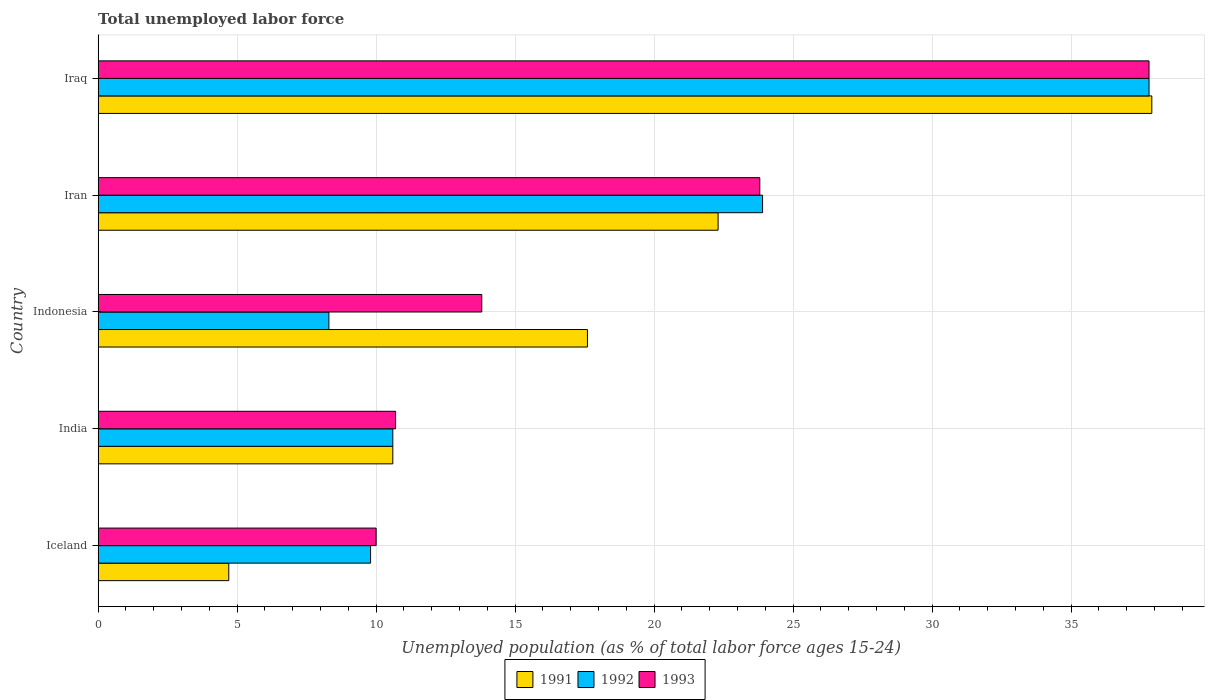How many different coloured bars are there?
Offer a terse response. 3. Are the number of bars per tick equal to the number of legend labels?
Make the answer very short. Yes. Are the number of bars on each tick of the Y-axis equal?
Give a very brief answer. Yes. How many bars are there on the 3rd tick from the top?
Provide a succinct answer. 3. How many bars are there on the 2nd tick from the bottom?
Give a very brief answer. 3. What is the percentage of unemployed population in in 1992 in Iran?
Your answer should be very brief. 23.9. Across all countries, what is the maximum percentage of unemployed population in in 1991?
Give a very brief answer. 37.9. Across all countries, what is the minimum percentage of unemployed population in in 1993?
Ensure brevity in your answer.  10. In which country was the percentage of unemployed population in in 1992 maximum?
Keep it short and to the point. Iraq. What is the total percentage of unemployed population in in 1993 in the graph?
Provide a short and direct response. 96.1. What is the difference between the percentage of unemployed population in in 1993 in Iceland and that in India?
Offer a very short reply. -0.7. What is the difference between the percentage of unemployed population in in 1993 in Iceland and the percentage of unemployed population in in 1992 in Iran?
Offer a terse response. -13.9. What is the average percentage of unemployed population in in 1992 per country?
Keep it short and to the point. 18.08. What is the difference between the percentage of unemployed population in in 1991 and percentage of unemployed population in in 1993 in Iraq?
Offer a very short reply. 0.1. What is the ratio of the percentage of unemployed population in in 1992 in Iceland to that in Iran?
Give a very brief answer. 0.41. Is the percentage of unemployed population in in 1991 in India less than that in Indonesia?
Your answer should be compact. Yes. What is the difference between the highest and the second highest percentage of unemployed population in in 1991?
Your response must be concise. 15.6. What is the difference between the highest and the lowest percentage of unemployed population in in 1992?
Provide a succinct answer. 29.5. How many bars are there?
Keep it short and to the point. 15. How many countries are there in the graph?
Your answer should be compact. 5. What is the difference between two consecutive major ticks on the X-axis?
Keep it short and to the point. 5. How are the legend labels stacked?
Ensure brevity in your answer.  Horizontal. What is the title of the graph?
Your answer should be compact. Total unemployed labor force. What is the label or title of the X-axis?
Provide a succinct answer. Unemployed population (as % of total labor force ages 15-24). What is the label or title of the Y-axis?
Make the answer very short. Country. What is the Unemployed population (as % of total labor force ages 15-24) in 1991 in Iceland?
Give a very brief answer. 4.7. What is the Unemployed population (as % of total labor force ages 15-24) of 1992 in Iceland?
Offer a terse response. 9.8. What is the Unemployed population (as % of total labor force ages 15-24) of 1993 in Iceland?
Your answer should be compact. 10. What is the Unemployed population (as % of total labor force ages 15-24) in 1991 in India?
Your answer should be very brief. 10.6. What is the Unemployed population (as % of total labor force ages 15-24) of 1992 in India?
Provide a succinct answer. 10.6. What is the Unemployed population (as % of total labor force ages 15-24) in 1993 in India?
Provide a succinct answer. 10.7. What is the Unemployed population (as % of total labor force ages 15-24) in 1991 in Indonesia?
Provide a succinct answer. 17.6. What is the Unemployed population (as % of total labor force ages 15-24) in 1992 in Indonesia?
Keep it short and to the point. 8.3. What is the Unemployed population (as % of total labor force ages 15-24) of 1993 in Indonesia?
Make the answer very short. 13.8. What is the Unemployed population (as % of total labor force ages 15-24) of 1991 in Iran?
Provide a succinct answer. 22.3. What is the Unemployed population (as % of total labor force ages 15-24) in 1992 in Iran?
Ensure brevity in your answer.  23.9. What is the Unemployed population (as % of total labor force ages 15-24) of 1993 in Iran?
Ensure brevity in your answer.  23.8. What is the Unemployed population (as % of total labor force ages 15-24) in 1991 in Iraq?
Offer a terse response. 37.9. What is the Unemployed population (as % of total labor force ages 15-24) of 1992 in Iraq?
Your response must be concise. 37.8. What is the Unemployed population (as % of total labor force ages 15-24) of 1993 in Iraq?
Ensure brevity in your answer.  37.8. Across all countries, what is the maximum Unemployed population (as % of total labor force ages 15-24) of 1991?
Provide a short and direct response. 37.9. Across all countries, what is the maximum Unemployed population (as % of total labor force ages 15-24) in 1992?
Provide a short and direct response. 37.8. Across all countries, what is the maximum Unemployed population (as % of total labor force ages 15-24) of 1993?
Keep it short and to the point. 37.8. Across all countries, what is the minimum Unemployed population (as % of total labor force ages 15-24) in 1991?
Keep it short and to the point. 4.7. Across all countries, what is the minimum Unemployed population (as % of total labor force ages 15-24) of 1992?
Offer a very short reply. 8.3. Across all countries, what is the minimum Unemployed population (as % of total labor force ages 15-24) of 1993?
Offer a terse response. 10. What is the total Unemployed population (as % of total labor force ages 15-24) in 1991 in the graph?
Keep it short and to the point. 93.1. What is the total Unemployed population (as % of total labor force ages 15-24) in 1992 in the graph?
Make the answer very short. 90.4. What is the total Unemployed population (as % of total labor force ages 15-24) in 1993 in the graph?
Ensure brevity in your answer.  96.1. What is the difference between the Unemployed population (as % of total labor force ages 15-24) in 1991 in Iceland and that in India?
Keep it short and to the point. -5.9. What is the difference between the Unemployed population (as % of total labor force ages 15-24) in 1992 in Iceland and that in India?
Give a very brief answer. -0.8. What is the difference between the Unemployed population (as % of total labor force ages 15-24) of 1993 in Iceland and that in India?
Your response must be concise. -0.7. What is the difference between the Unemployed population (as % of total labor force ages 15-24) of 1993 in Iceland and that in Indonesia?
Ensure brevity in your answer.  -3.8. What is the difference between the Unemployed population (as % of total labor force ages 15-24) in 1991 in Iceland and that in Iran?
Make the answer very short. -17.6. What is the difference between the Unemployed population (as % of total labor force ages 15-24) of 1992 in Iceland and that in Iran?
Your answer should be compact. -14.1. What is the difference between the Unemployed population (as % of total labor force ages 15-24) in 1993 in Iceland and that in Iran?
Keep it short and to the point. -13.8. What is the difference between the Unemployed population (as % of total labor force ages 15-24) in 1991 in Iceland and that in Iraq?
Keep it short and to the point. -33.2. What is the difference between the Unemployed population (as % of total labor force ages 15-24) in 1993 in Iceland and that in Iraq?
Your answer should be compact. -27.8. What is the difference between the Unemployed population (as % of total labor force ages 15-24) in 1993 in India and that in Indonesia?
Provide a short and direct response. -3.1. What is the difference between the Unemployed population (as % of total labor force ages 15-24) in 1991 in India and that in Iran?
Offer a terse response. -11.7. What is the difference between the Unemployed population (as % of total labor force ages 15-24) in 1993 in India and that in Iran?
Keep it short and to the point. -13.1. What is the difference between the Unemployed population (as % of total labor force ages 15-24) in 1991 in India and that in Iraq?
Ensure brevity in your answer.  -27.3. What is the difference between the Unemployed population (as % of total labor force ages 15-24) of 1992 in India and that in Iraq?
Give a very brief answer. -27.2. What is the difference between the Unemployed population (as % of total labor force ages 15-24) in 1993 in India and that in Iraq?
Provide a succinct answer. -27.1. What is the difference between the Unemployed population (as % of total labor force ages 15-24) in 1992 in Indonesia and that in Iran?
Your answer should be compact. -15.6. What is the difference between the Unemployed population (as % of total labor force ages 15-24) of 1991 in Indonesia and that in Iraq?
Ensure brevity in your answer.  -20.3. What is the difference between the Unemployed population (as % of total labor force ages 15-24) in 1992 in Indonesia and that in Iraq?
Your answer should be compact. -29.5. What is the difference between the Unemployed population (as % of total labor force ages 15-24) in 1991 in Iran and that in Iraq?
Your answer should be very brief. -15.6. What is the difference between the Unemployed population (as % of total labor force ages 15-24) in 1992 in Iran and that in Iraq?
Keep it short and to the point. -13.9. What is the difference between the Unemployed population (as % of total labor force ages 15-24) of 1993 in Iran and that in Iraq?
Make the answer very short. -14. What is the difference between the Unemployed population (as % of total labor force ages 15-24) in 1991 in Iceland and the Unemployed population (as % of total labor force ages 15-24) in 1992 in India?
Keep it short and to the point. -5.9. What is the difference between the Unemployed population (as % of total labor force ages 15-24) in 1991 in Iceland and the Unemployed population (as % of total labor force ages 15-24) in 1993 in India?
Provide a succinct answer. -6. What is the difference between the Unemployed population (as % of total labor force ages 15-24) in 1991 in Iceland and the Unemployed population (as % of total labor force ages 15-24) in 1992 in Iran?
Give a very brief answer. -19.2. What is the difference between the Unemployed population (as % of total labor force ages 15-24) in 1991 in Iceland and the Unemployed population (as % of total labor force ages 15-24) in 1993 in Iran?
Keep it short and to the point. -19.1. What is the difference between the Unemployed population (as % of total labor force ages 15-24) in 1991 in Iceland and the Unemployed population (as % of total labor force ages 15-24) in 1992 in Iraq?
Your response must be concise. -33.1. What is the difference between the Unemployed population (as % of total labor force ages 15-24) of 1991 in Iceland and the Unemployed population (as % of total labor force ages 15-24) of 1993 in Iraq?
Make the answer very short. -33.1. What is the difference between the Unemployed population (as % of total labor force ages 15-24) of 1992 in India and the Unemployed population (as % of total labor force ages 15-24) of 1993 in Indonesia?
Offer a terse response. -3.2. What is the difference between the Unemployed population (as % of total labor force ages 15-24) of 1992 in India and the Unemployed population (as % of total labor force ages 15-24) of 1993 in Iran?
Provide a succinct answer. -13.2. What is the difference between the Unemployed population (as % of total labor force ages 15-24) of 1991 in India and the Unemployed population (as % of total labor force ages 15-24) of 1992 in Iraq?
Provide a succinct answer. -27.2. What is the difference between the Unemployed population (as % of total labor force ages 15-24) of 1991 in India and the Unemployed population (as % of total labor force ages 15-24) of 1993 in Iraq?
Ensure brevity in your answer.  -27.2. What is the difference between the Unemployed population (as % of total labor force ages 15-24) of 1992 in India and the Unemployed population (as % of total labor force ages 15-24) of 1993 in Iraq?
Your response must be concise. -27.2. What is the difference between the Unemployed population (as % of total labor force ages 15-24) of 1991 in Indonesia and the Unemployed population (as % of total labor force ages 15-24) of 1992 in Iran?
Your answer should be very brief. -6.3. What is the difference between the Unemployed population (as % of total labor force ages 15-24) in 1991 in Indonesia and the Unemployed population (as % of total labor force ages 15-24) in 1993 in Iran?
Your answer should be compact. -6.2. What is the difference between the Unemployed population (as % of total labor force ages 15-24) of 1992 in Indonesia and the Unemployed population (as % of total labor force ages 15-24) of 1993 in Iran?
Keep it short and to the point. -15.5. What is the difference between the Unemployed population (as % of total labor force ages 15-24) in 1991 in Indonesia and the Unemployed population (as % of total labor force ages 15-24) in 1992 in Iraq?
Provide a succinct answer. -20.2. What is the difference between the Unemployed population (as % of total labor force ages 15-24) in 1991 in Indonesia and the Unemployed population (as % of total labor force ages 15-24) in 1993 in Iraq?
Ensure brevity in your answer.  -20.2. What is the difference between the Unemployed population (as % of total labor force ages 15-24) of 1992 in Indonesia and the Unemployed population (as % of total labor force ages 15-24) of 1993 in Iraq?
Your response must be concise. -29.5. What is the difference between the Unemployed population (as % of total labor force ages 15-24) in 1991 in Iran and the Unemployed population (as % of total labor force ages 15-24) in 1992 in Iraq?
Offer a very short reply. -15.5. What is the difference between the Unemployed population (as % of total labor force ages 15-24) of 1991 in Iran and the Unemployed population (as % of total labor force ages 15-24) of 1993 in Iraq?
Your response must be concise. -15.5. What is the difference between the Unemployed population (as % of total labor force ages 15-24) in 1992 in Iran and the Unemployed population (as % of total labor force ages 15-24) in 1993 in Iraq?
Your response must be concise. -13.9. What is the average Unemployed population (as % of total labor force ages 15-24) in 1991 per country?
Keep it short and to the point. 18.62. What is the average Unemployed population (as % of total labor force ages 15-24) in 1992 per country?
Keep it short and to the point. 18.08. What is the average Unemployed population (as % of total labor force ages 15-24) in 1993 per country?
Offer a very short reply. 19.22. What is the difference between the Unemployed population (as % of total labor force ages 15-24) in 1992 and Unemployed population (as % of total labor force ages 15-24) in 1993 in India?
Offer a very short reply. -0.1. What is the difference between the Unemployed population (as % of total labor force ages 15-24) of 1992 and Unemployed population (as % of total labor force ages 15-24) of 1993 in Indonesia?
Ensure brevity in your answer.  -5.5. What is the difference between the Unemployed population (as % of total labor force ages 15-24) in 1991 and Unemployed population (as % of total labor force ages 15-24) in 1992 in Iran?
Make the answer very short. -1.6. What is the difference between the Unemployed population (as % of total labor force ages 15-24) in 1991 and Unemployed population (as % of total labor force ages 15-24) in 1993 in Iran?
Provide a succinct answer. -1.5. What is the difference between the Unemployed population (as % of total labor force ages 15-24) of 1992 and Unemployed population (as % of total labor force ages 15-24) of 1993 in Iran?
Your response must be concise. 0.1. What is the difference between the Unemployed population (as % of total labor force ages 15-24) of 1992 and Unemployed population (as % of total labor force ages 15-24) of 1993 in Iraq?
Offer a very short reply. 0. What is the ratio of the Unemployed population (as % of total labor force ages 15-24) of 1991 in Iceland to that in India?
Give a very brief answer. 0.44. What is the ratio of the Unemployed population (as % of total labor force ages 15-24) of 1992 in Iceland to that in India?
Provide a short and direct response. 0.92. What is the ratio of the Unemployed population (as % of total labor force ages 15-24) in 1993 in Iceland to that in India?
Give a very brief answer. 0.93. What is the ratio of the Unemployed population (as % of total labor force ages 15-24) in 1991 in Iceland to that in Indonesia?
Offer a very short reply. 0.27. What is the ratio of the Unemployed population (as % of total labor force ages 15-24) of 1992 in Iceland to that in Indonesia?
Ensure brevity in your answer.  1.18. What is the ratio of the Unemployed population (as % of total labor force ages 15-24) of 1993 in Iceland to that in Indonesia?
Provide a succinct answer. 0.72. What is the ratio of the Unemployed population (as % of total labor force ages 15-24) of 1991 in Iceland to that in Iran?
Your answer should be compact. 0.21. What is the ratio of the Unemployed population (as % of total labor force ages 15-24) in 1992 in Iceland to that in Iran?
Your answer should be very brief. 0.41. What is the ratio of the Unemployed population (as % of total labor force ages 15-24) of 1993 in Iceland to that in Iran?
Keep it short and to the point. 0.42. What is the ratio of the Unemployed population (as % of total labor force ages 15-24) in 1991 in Iceland to that in Iraq?
Your response must be concise. 0.12. What is the ratio of the Unemployed population (as % of total labor force ages 15-24) in 1992 in Iceland to that in Iraq?
Offer a very short reply. 0.26. What is the ratio of the Unemployed population (as % of total labor force ages 15-24) of 1993 in Iceland to that in Iraq?
Provide a short and direct response. 0.26. What is the ratio of the Unemployed population (as % of total labor force ages 15-24) of 1991 in India to that in Indonesia?
Your answer should be compact. 0.6. What is the ratio of the Unemployed population (as % of total labor force ages 15-24) of 1992 in India to that in Indonesia?
Keep it short and to the point. 1.28. What is the ratio of the Unemployed population (as % of total labor force ages 15-24) of 1993 in India to that in Indonesia?
Your response must be concise. 0.78. What is the ratio of the Unemployed population (as % of total labor force ages 15-24) in 1991 in India to that in Iran?
Give a very brief answer. 0.48. What is the ratio of the Unemployed population (as % of total labor force ages 15-24) of 1992 in India to that in Iran?
Provide a succinct answer. 0.44. What is the ratio of the Unemployed population (as % of total labor force ages 15-24) of 1993 in India to that in Iran?
Ensure brevity in your answer.  0.45. What is the ratio of the Unemployed population (as % of total labor force ages 15-24) in 1991 in India to that in Iraq?
Offer a very short reply. 0.28. What is the ratio of the Unemployed population (as % of total labor force ages 15-24) of 1992 in India to that in Iraq?
Offer a very short reply. 0.28. What is the ratio of the Unemployed population (as % of total labor force ages 15-24) of 1993 in India to that in Iraq?
Your answer should be compact. 0.28. What is the ratio of the Unemployed population (as % of total labor force ages 15-24) in 1991 in Indonesia to that in Iran?
Your answer should be very brief. 0.79. What is the ratio of the Unemployed population (as % of total labor force ages 15-24) of 1992 in Indonesia to that in Iran?
Offer a very short reply. 0.35. What is the ratio of the Unemployed population (as % of total labor force ages 15-24) of 1993 in Indonesia to that in Iran?
Provide a succinct answer. 0.58. What is the ratio of the Unemployed population (as % of total labor force ages 15-24) in 1991 in Indonesia to that in Iraq?
Your response must be concise. 0.46. What is the ratio of the Unemployed population (as % of total labor force ages 15-24) in 1992 in Indonesia to that in Iraq?
Offer a very short reply. 0.22. What is the ratio of the Unemployed population (as % of total labor force ages 15-24) of 1993 in Indonesia to that in Iraq?
Give a very brief answer. 0.37. What is the ratio of the Unemployed population (as % of total labor force ages 15-24) in 1991 in Iran to that in Iraq?
Provide a short and direct response. 0.59. What is the ratio of the Unemployed population (as % of total labor force ages 15-24) in 1992 in Iran to that in Iraq?
Your answer should be very brief. 0.63. What is the ratio of the Unemployed population (as % of total labor force ages 15-24) in 1993 in Iran to that in Iraq?
Your answer should be very brief. 0.63. What is the difference between the highest and the second highest Unemployed population (as % of total labor force ages 15-24) in 1992?
Your response must be concise. 13.9. What is the difference between the highest and the second highest Unemployed population (as % of total labor force ages 15-24) in 1993?
Give a very brief answer. 14. What is the difference between the highest and the lowest Unemployed population (as % of total labor force ages 15-24) in 1991?
Make the answer very short. 33.2. What is the difference between the highest and the lowest Unemployed population (as % of total labor force ages 15-24) in 1992?
Offer a very short reply. 29.5. What is the difference between the highest and the lowest Unemployed population (as % of total labor force ages 15-24) in 1993?
Your response must be concise. 27.8. 